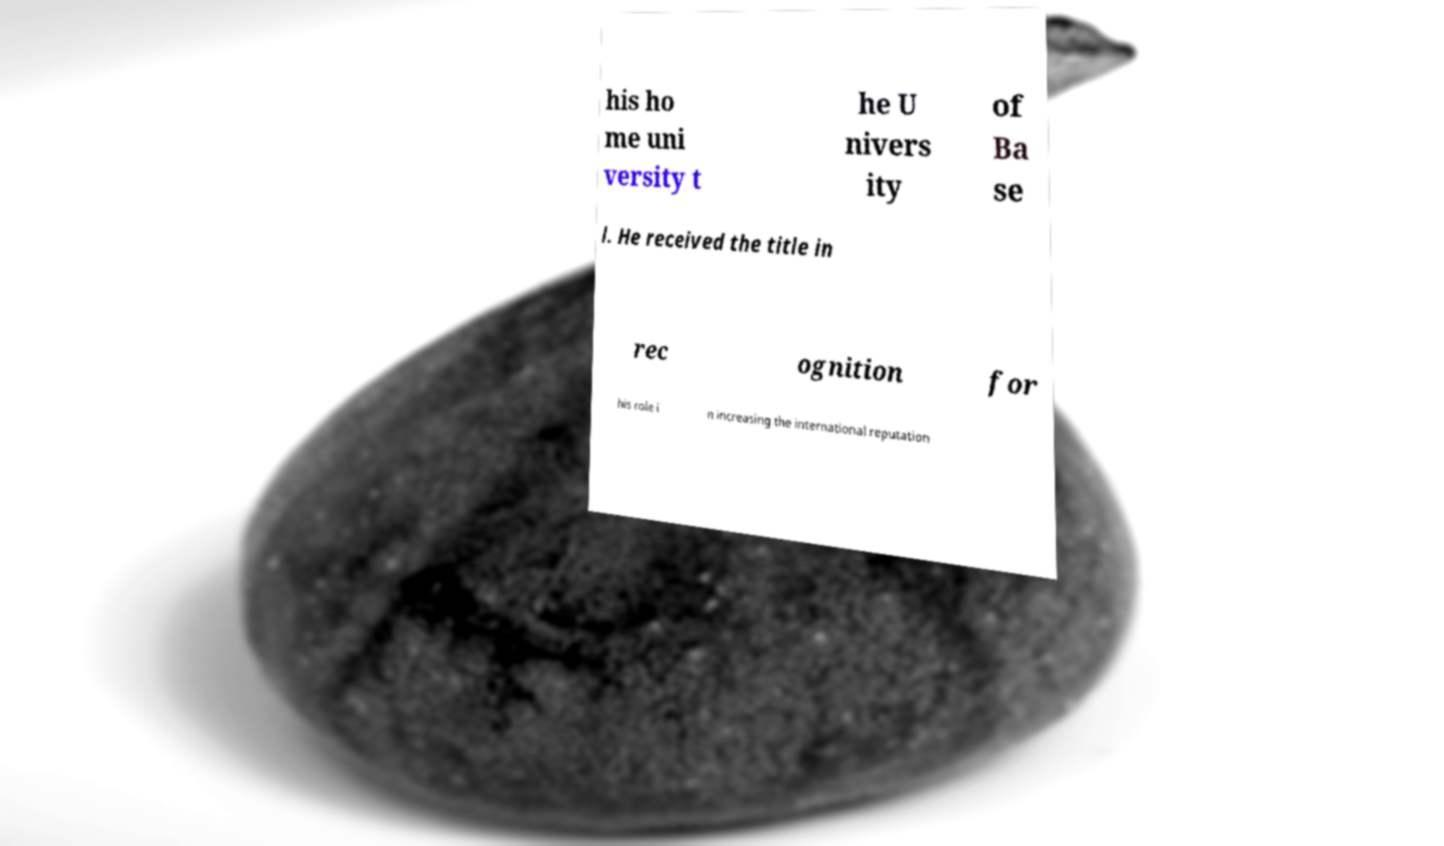Can you accurately transcribe the text from the provided image for me? his ho me uni versity t he U nivers ity of Ba se l. He received the title in rec ognition for his role i n increasing the international reputation 